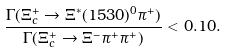Convert formula to latex. <formula><loc_0><loc_0><loc_500><loc_500>\frac { \Gamma ( \Xi _ { c } ^ { + } \rightarrow \Xi ^ { * } ( 1 5 3 0 ) ^ { 0 } \pi ^ { + } ) } { \Gamma ( \Xi _ { c } ^ { + } \rightarrow \Xi ^ { - } \pi ^ { + } \pi ^ { + } ) } < 0 . 1 0 .</formula> 